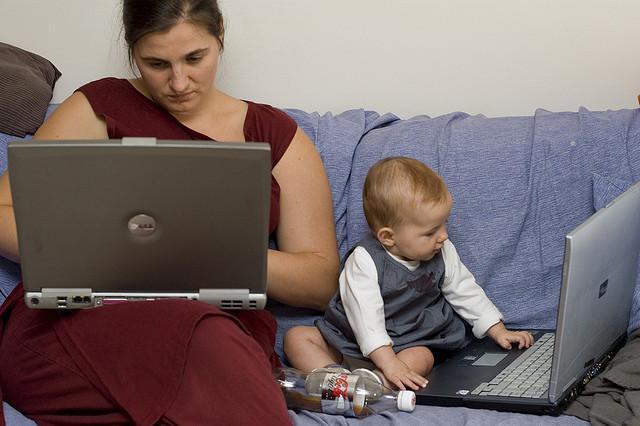How many laptops are there?
Give a very brief answer. 2. How many computers?
Give a very brief answer. 2. How many people are in the photo?
Give a very brief answer. 2. How many donuts are there?
Give a very brief answer. 0. 